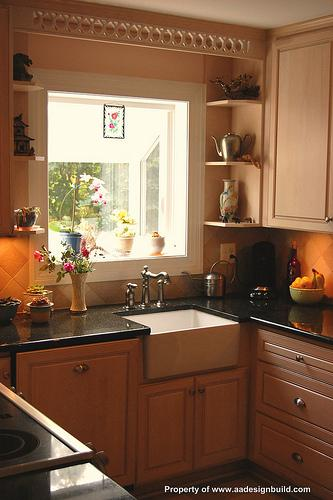Question: why the room bright?
Choices:
A. The lights are on.
B. The walls are yellow.
C. The window is open.
D. There are numerous candles lit.
Answer with the letter. Answer: C Question: what is the color of the counter?
Choices:
A. White.
B. Gray.
C. Brown.
D. Black.
Answer with the letter. Answer: D Question: what is the color of the flowers?
Choices:
A. Purple.
B. Pink.
C. Yellow.
D. Red.
Answer with the letter. Answer: B Question: how many fruit bowls on the counter?
Choices:
A. Two.
B. Three.
C. One.
D. Four.
Answer with the letter. Answer: C 